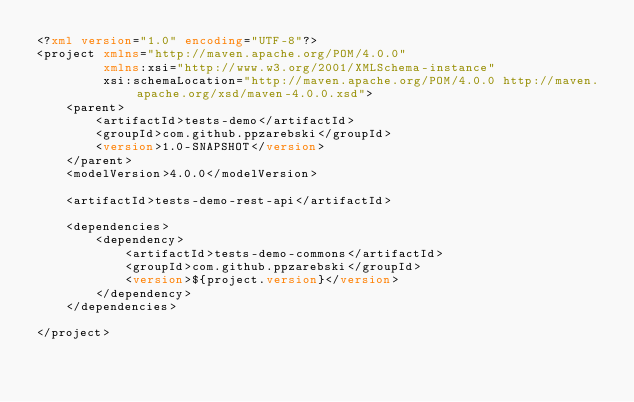Convert code to text. <code><loc_0><loc_0><loc_500><loc_500><_XML_><?xml version="1.0" encoding="UTF-8"?>
<project xmlns="http://maven.apache.org/POM/4.0.0"
         xmlns:xsi="http://www.w3.org/2001/XMLSchema-instance"
         xsi:schemaLocation="http://maven.apache.org/POM/4.0.0 http://maven.apache.org/xsd/maven-4.0.0.xsd">
    <parent>
        <artifactId>tests-demo</artifactId>
        <groupId>com.github.ppzarebski</groupId>
        <version>1.0-SNAPSHOT</version>
    </parent>
    <modelVersion>4.0.0</modelVersion>

    <artifactId>tests-demo-rest-api</artifactId>

    <dependencies>
        <dependency>
            <artifactId>tests-demo-commons</artifactId>
            <groupId>com.github.ppzarebski</groupId>
            <version>${project.version}</version>
        </dependency>
    </dependencies>

</project></code> 